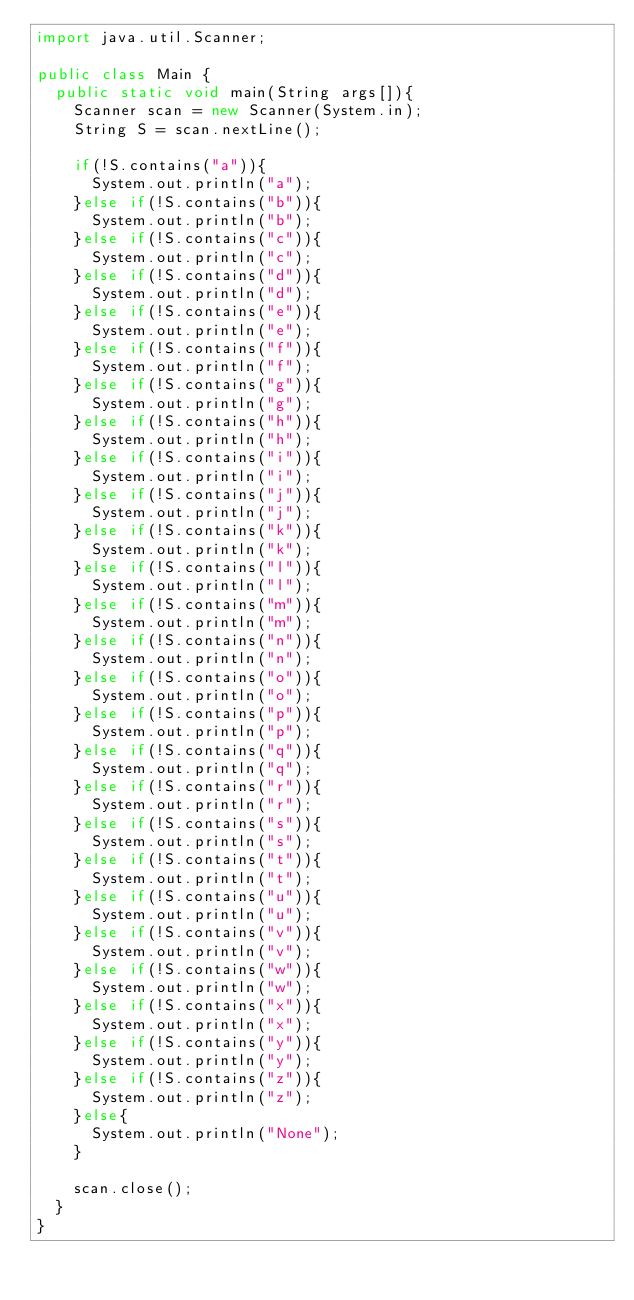Convert code to text. <code><loc_0><loc_0><loc_500><loc_500><_Java_>import java.util.Scanner;

public class Main {
	public static void main(String args[]){
		Scanner scan = new Scanner(System.in);
		String S = scan.nextLine();

		if(!S.contains("a")){
			System.out.println("a");
		}else if(!S.contains("b")){
			System.out.println("b");
		}else if(!S.contains("c")){
			System.out.println("c");
		}else if(!S.contains("d")){
			System.out.println("d");
		}else if(!S.contains("e")){
			System.out.println("e");
		}else if(!S.contains("f")){
			System.out.println("f");
		}else if(!S.contains("g")){
			System.out.println("g");
		}else if(!S.contains("h")){
			System.out.println("h");
		}else if(!S.contains("i")){
			System.out.println("i");
		}else if(!S.contains("j")){
			System.out.println("j");
		}else if(!S.contains("k")){
			System.out.println("k");
		}else if(!S.contains("l")){
			System.out.println("l");
		}else if(!S.contains("m")){
			System.out.println("m");
		}else if(!S.contains("n")){
			System.out.println("n");
		}else if(!S.contains("o")){
			System.out.println("o");
		}else if(!S.contains("p")){
			System.out.println("p");
		}else if(!S.contains("q")){
			System.out.println("q");
		}else if(!S.contains("r")){
			System.out.println("r");
		}else if(!S.contains("s")){
			System.out.println("s");
		}else if(!S.contains("t")){
			System.out.println("t");
		}else if(!S.contains("u")){
			System.out.println("u");
		}else if(!S.contains("v")){
			System.out.println("v");
		}else if(!S.contains("w")){
			System.out.println("w");
		}else if(!S.contains("x")){
			System.out.println("x");
		}else if(!S.contains("y")){
			System.out.println("y");
		}else if(!S.contains("z")){
			System.out.println("z");
		}else{
			System.out.println("None");
		}

		scan.close();
	}
}</code> 